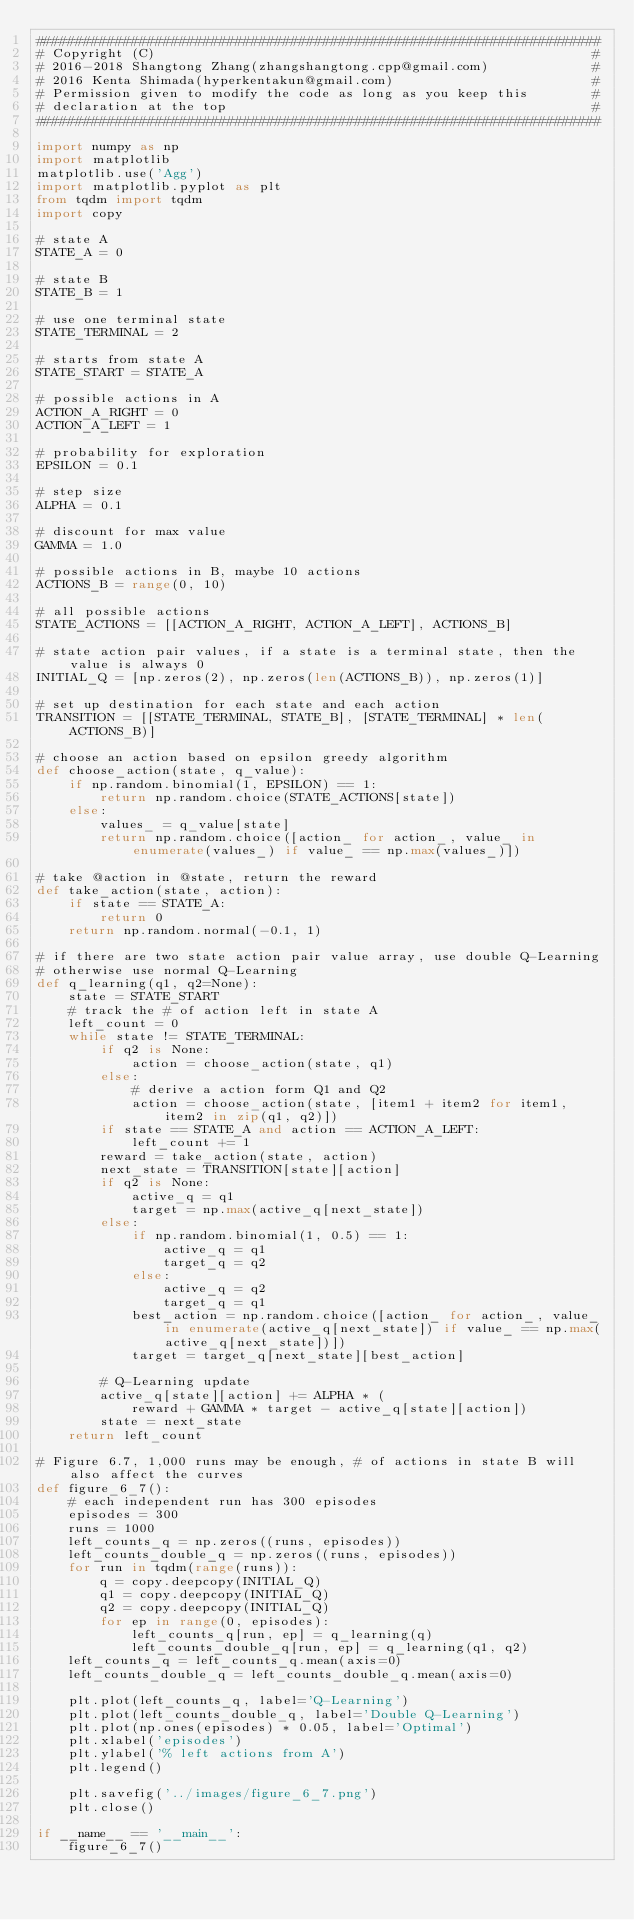<code> <loc_0><loc_0><loc_500><loc_500><_Python_>#######################################################################
# Copyright (C)                                                       #
# 2016-2018 Shangtong Zhang(zhangshangtong.cpp@gmail.com)             #
# 2016 Kenta Shimada(hyperkentakun@gmail.com)                         #
# Permission given to modify the code as long as you keep this        #
# declaration at the top                                              #
#######################################################################

import numpy as np
import matplotlib
matplotlib.use('Agg')
import matplotlib.pyplot as plt
from tqdm import tqdm
import copy

# state A
STATE_A = 0

# state B
STATE_B = 1

# use one terminal state
STATE_TERMINAL = 2

# starts from state A
STATE_START = STATE_A

# possible actions in A
ACTION_A_RIGHT = 0
ACTION_A_LEFT = 1

# probability for exploration
EPSILON = 0.1

# step size
ALPHA = 0.1

# discount for max value
GAMMA = 1.0

# possible actions in B, maybe 10 actions
ACTIONS_B = range(0, 10)

# all possible actions
STATE_ACTIONS = [[ACTION_A_RIGHT, ACTION_A_LEFT], ACTIONS_B]

# state action pair values, if a state is a terminal state, then the value is always 0
INITIAL_Q = [np.zeros(2), np.zeros(len(ACTIONS_B)), np.zeros(1)]

# set up destination for each state and each action
TRANSITION = [[STATE_TERMINAL, STATE_B], [STATE_TERMINAL] * len(ACTIONS_B)]

# choose an action based on epsilon greedy algorithm
def choose_action(state, q_value):
    if np.random.binomial(1, EPSILON) == 1:
        return np.random.choice(STATE_ACTIONS[state])
    else:
        values_ = q_value[state]
        return np.random.choice([action_ for action_, value_ in enumerate(values_) if value_ == np.max(values_)])

# take @action in @state, return the reward
def take_action(state, action):
    if state == STATE_A:
        return 0
    return np.random.normal(-0.1, 1)

# if there are two state action pair value array, use double Q-Learning
# otherwise use normal Q-Learning
def q_learning(q1, q2=None):
    state = STATE_START
    # track the # of action left in state A
    left_count = 0
    while state != STATE_TERMINAL:
        if q2 is None:
            action = choose_action(state, q1)
        else:
            # derive a action form Q1 and Q2
            action = choose_action(state, [item1 + item2 for item1, item2 in zip(q1, q2)])
        if state == STATE_A and action == ACTION_A_LEFT:
            left_count += 1
        reward = take_action(state, action)
        next_state = TRANSITION[state][action]
        if q2 is None:
            active_q = q1
            target = np.max(active_q[next_state])
        else:
            if np.random.binomial(1, 0.5) == 1:
                active_q = q1
                target_q = q2
            else:
                active_q = q2
                target_q = q1
            best_action = np.random.choice([action_ for action_, value_ in enumerate(active_q[next_state]) if value_ == np.max(active_q[next_state])])
            target = target_q[next_state][best_action]

        # Q-Learning update
        active_q[state][action] += ALPHA * (
            reward + GAMMA * target - active_q[state][action])
        state = next_state
    return left_count

# Figure 6.7, 1,000 runs may be enough, # of actions in state B will also affect the curves
def figure_6_7():
    # each independent run has 300 episodes
    episodes = 300
    runs = 1000
    left_counts_q = np.zeros((runs, episodes))
    left_counts_double_q = np.zeros((runs, episodes))
    for run in tqdm(range(runs)):
        q = copy.deepcopy(INITIAL_Q)
        q1 = copy.deepcopy(INITIAL_Q)
        q2 = copy.deepcopy(INITIAL_Q)
        for ep in range(0, episodes):
            left_counts_q[run, ep] = q_learning(q)
            left_counts_double_q[run, ep] = q_learning(q1, q2)
    left_counts_q = left_counts_q.mean(axis=0)
    left_counts_double_q = left_counts_double_q.mean(axis=0)

    plt.plot(left_counts_q, label='Q-Learning')
    plt.plot(left_counts_double_q, label='Double Q-Learning')
    plt.plot(np.ones(episodes) * 0.05, label='Optimal')
    plt.xlabel('episodes')
    plt.ylabel('% left actions from A')
    plt.legend()

    plt.savefig('../images/figure_6_7.png')
    plt.close()

if __name__ == '__main__':
    figure_6_7()</code> 